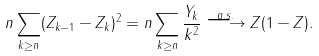Convert formula to latex. <formula><loc_0><loc_0><loc_500><loc_500>n \sum _ { k \geq n } ( Z _ { k - 1 } - Z _ { k } ) ^ { 2 } = n \sum _ { k \geq n } \frac { Y _ { k } } { k ^ { 2 } } \overset { a . s . } \longrightarrow Z ( 1 - Z ) .</formula> 